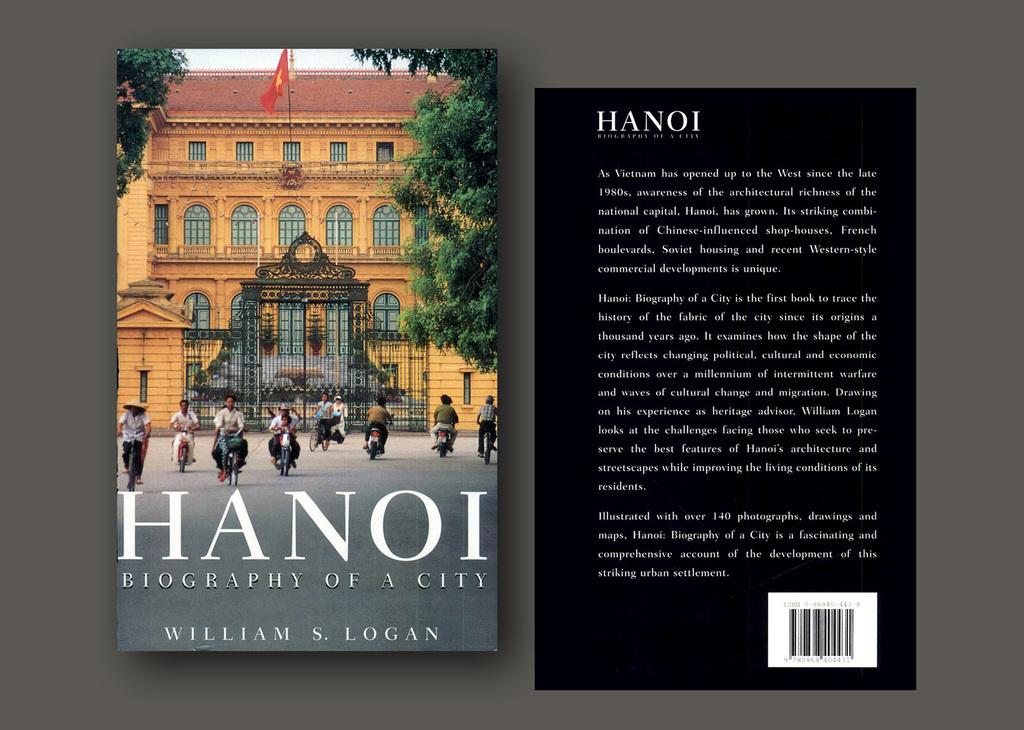<image>
Present a compact description of the photo's key features. The cover and backside of a book titled Hanoi Biography of a City. 